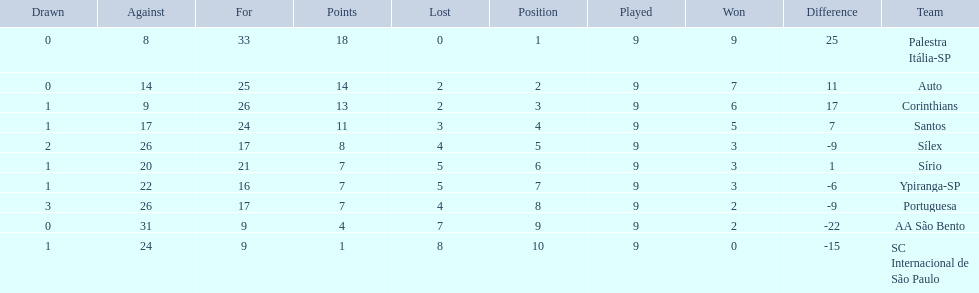Which teams were playing brazilian football in 1926? Palestra Itália-SP, Auto, Corinthians, Santos, Sílex, Sírio, Ypiranga-SP, Portuguesa, AA São Bento, SC Internacional de São Paulo. Of those teams, which one scored 13 points? Corinthians. 